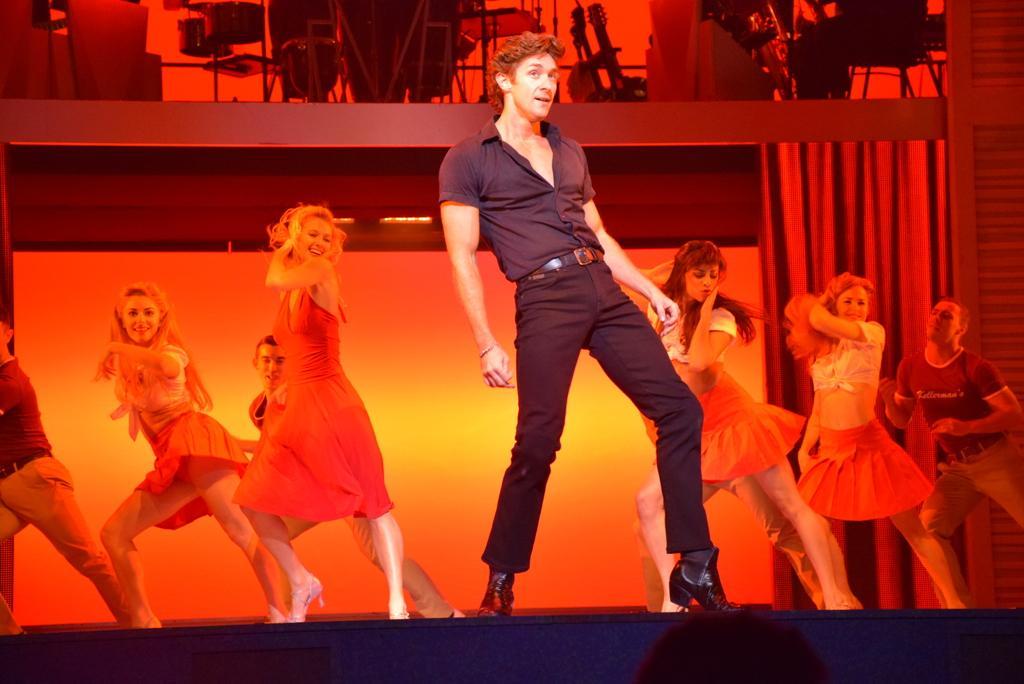How would you summarize this image in a sentence or two? In this image, we can see people performing dance on the stage and in the background, there is a curtain and we can see a screen. At the top, there are stands and we can see some other objects. 